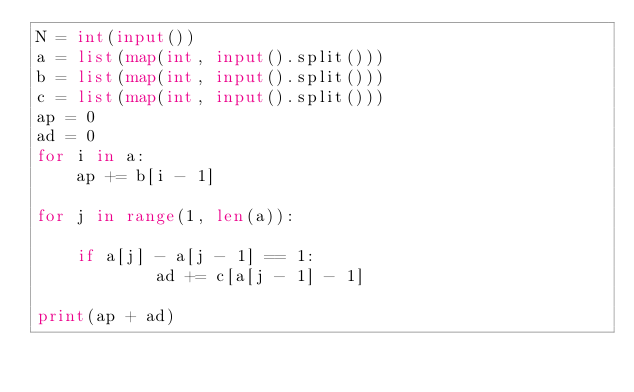<code> <loc_0><loc_0><loc_500><loc_500><_Python_>N = int(input())
a = list(map(int, input().split()))
b = list(map(int, input().split()))
c = list(map(int, input().split()))
ap = 0
ad = 0
for i in a:
    ap += b[i - 1]
    
for j in range(1, len(a)):
    
    if a[j] - a[j - 1] == 1:
            ad += c[a[j - 1] - 1]

print(ap + ad)</code> 